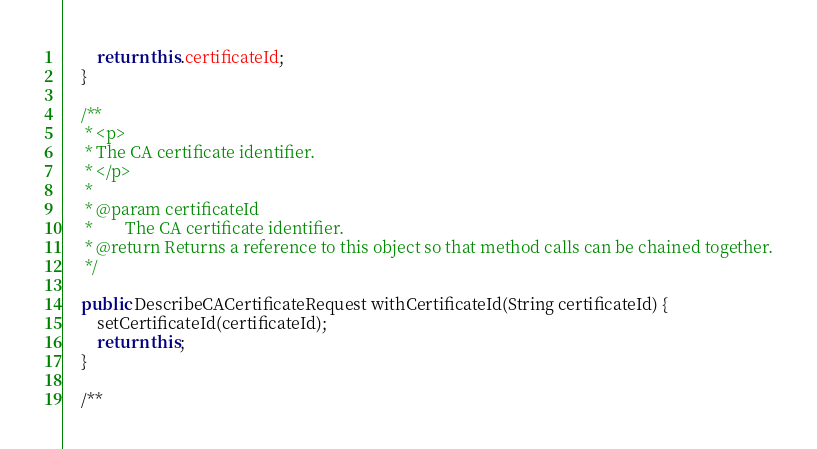<code> <loc_0><loc_0><loc_500><loc_500><_Java_>        return this.certificateId;
    }

    /**
     * <p>
     * The CA certificate identifier.
     * </p>
     * 
     * @param certificateId
     *        The CA certificate identifier.
     * @return Returns a reference to this object so that method calls can be chained together.
     */

    public DescribeCACertificateRequest withCertificateId(String certificateId) {
        setCertificateId(certificateId);
        return this;
    }

    /**</code> 